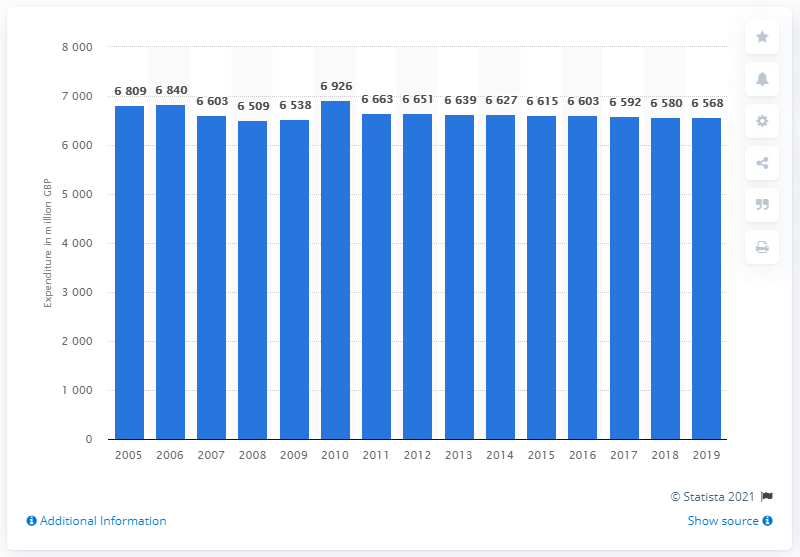Point out several critical features in this image. In 2019, households in the UK purchased approximately 6538 pounds worth of hairdressing services. 